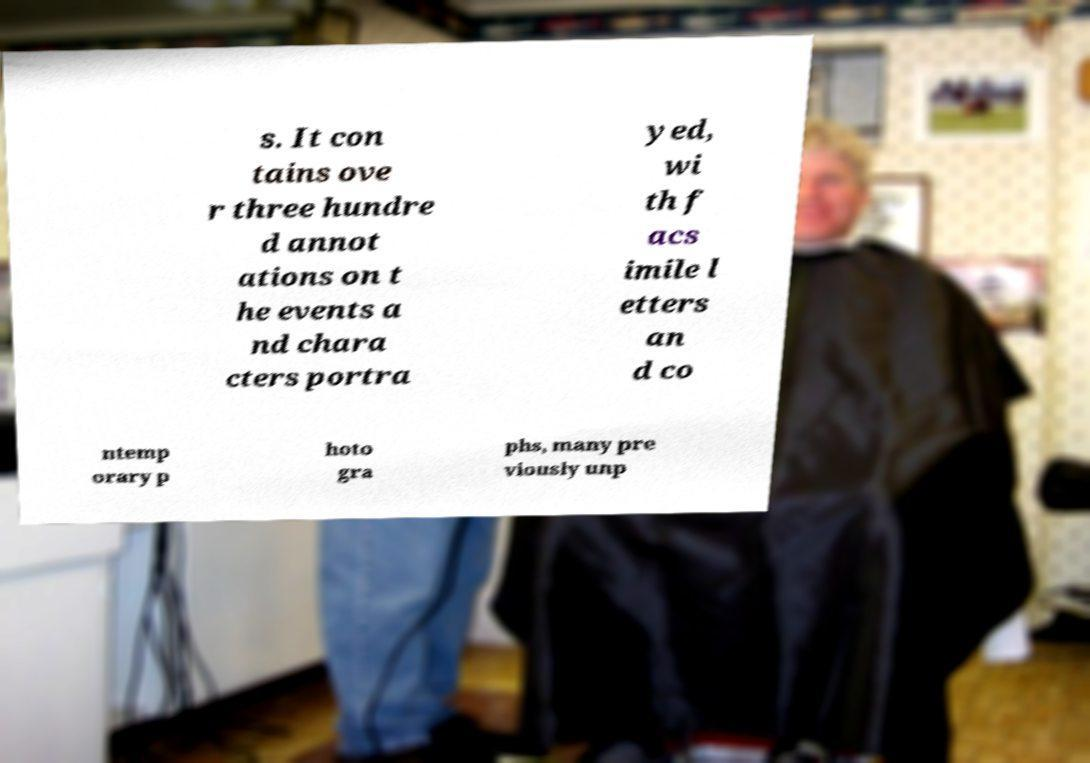For documentation purposes, I need the text within this image transcribed. Could you provide that? s. It con tains ove r three hundre d annot ations on t he events a nd chara cters portra yed, wi th f acs imile l etters an d co ntemp orary p hoto gra phs, many pre viously unp 